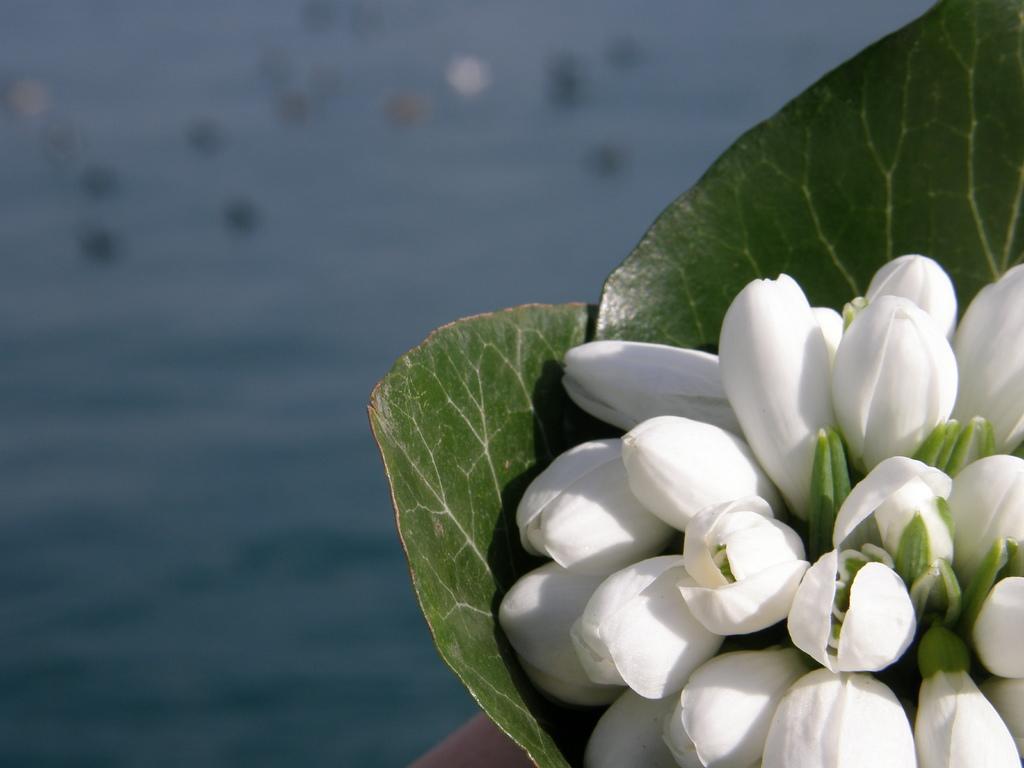In one or two sentences, can you explain what this image depicts? This image consists of flowers. At the bottom, there is water. And we can see green leaves. 